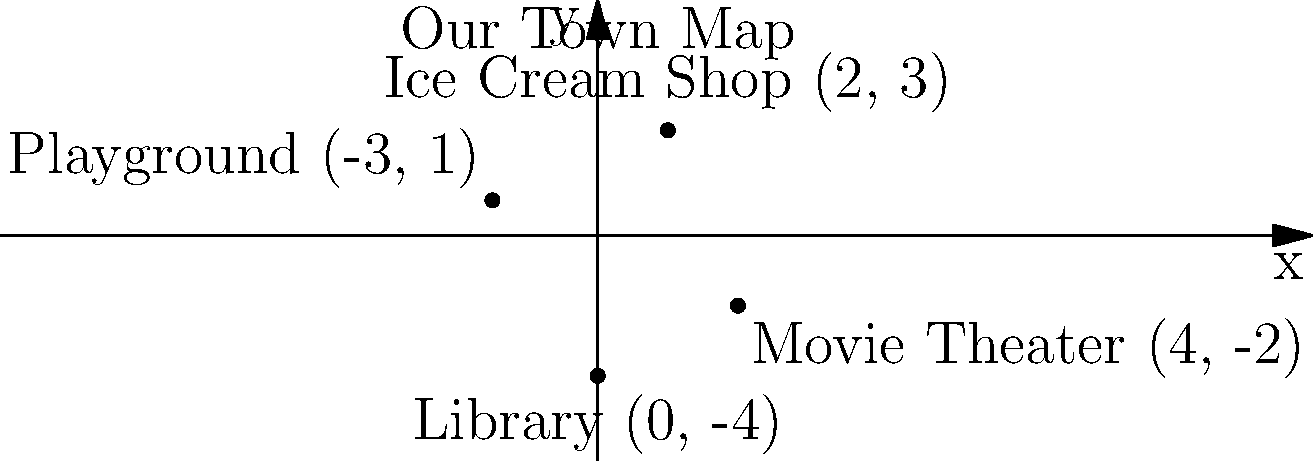Hey, remember our favorite spots back home? I've plotted some of them on this coordinate plane. Can you tell me the total distance between the Ice Cream Shop and the Library, following the grid lines (no diagonal shortcuts!)? To find the total distance between the Ice Cream Shop and the Library following the grid lines, we need to:

1. Identify the coordinates:
   - Ice Cream Shop: $(2, 3)$
   - Library: $(0, -4)$

2. Calculate the horizontal distance:
   - Difference in x-coordinates: $|2 - 0| = 2$

3. Calculate the vertical distance:
   - Difference in y-coordinates: $|3 - (-4)| = |3 + 4| = 7$

4. Sum up the total distance:
   - Total distance = Horizontal distance + Vertical distance
   - Total distance = $2 + 7 = 9$

The total distance following the grid lines is 9 units.
Answer: 9 units 